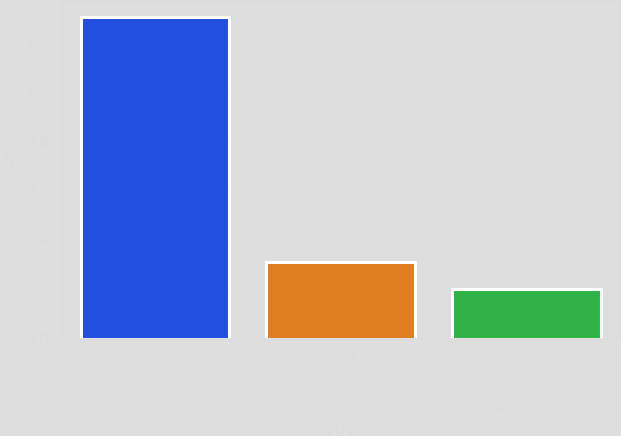Convert chart. <chart><loc_0><loc_0><loc_500><loc_500><bar_chart><fcel>Electric residential (a)<fcel>Electric C&I<fcel>Total retail electric sales<nl><fcel>1.3<fcel>0.31<fcel>0.2<nl></chart> 